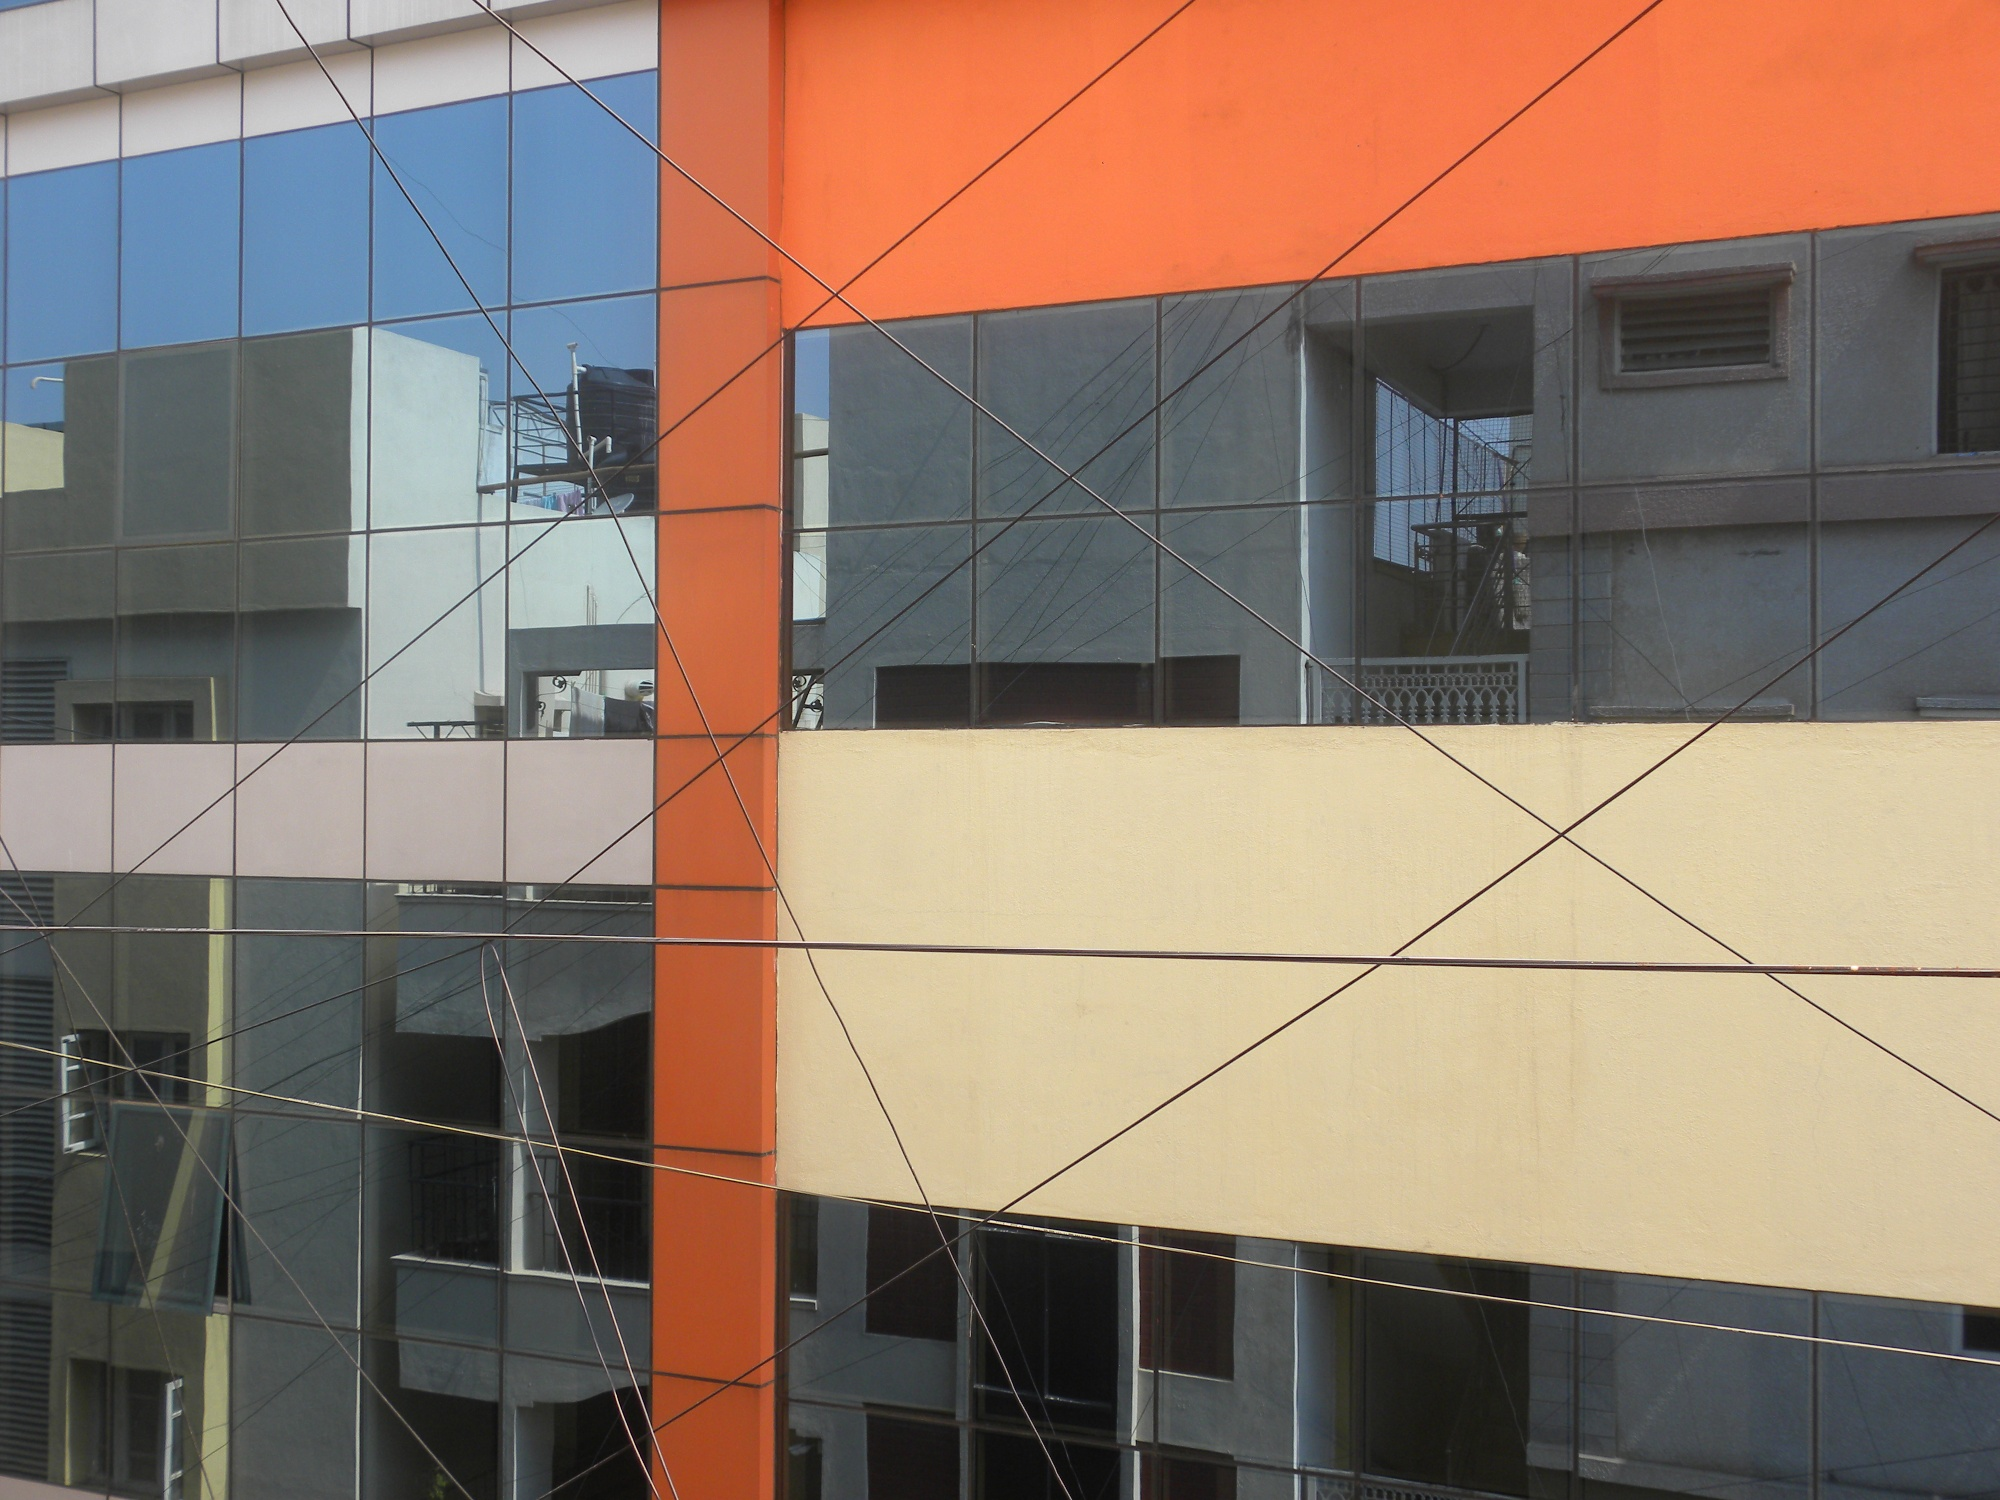What realistic scenarios might play out in this building? In a realistic scenario, this building could house a start-up tech company on its top floor. The large glass windows provide an open and inspiring workspace for the employees. The team collaborates on innovative projects, often stepping out onto the balcony for brainstorming sessions, enjoying the city's skyline. On the ground floor, a trendy café attracts both residents and office workers, creating a bustling, vibrant environment throughout the day. 
In a shorter scenario, a resident living on the second floor enjoys their morning routine of sipping coffee by the window, watching the city's hustle and bustle, feeling connected yet comfortably secluded within their modern home. 